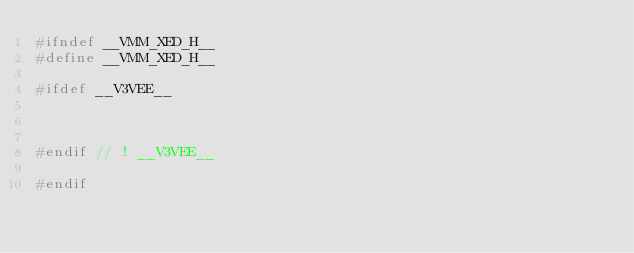<code> <loc_0><loc_0><loc_500><loc_500><_C_>#ifndef __VMM_XED_H__
#define __VMM_XED_H__

#ifdef __V3VEE__



#endif // ! __V3VEE__

#endif
</code> 